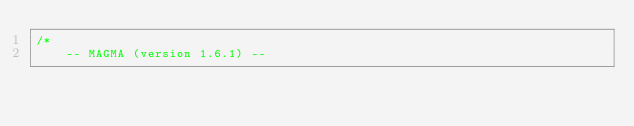Convert code to text. <code><loc_0><loc_0><loc_500><loc_500><_Cuda_>/*
    -- MAGMA (version 1.6.1) --</code> 